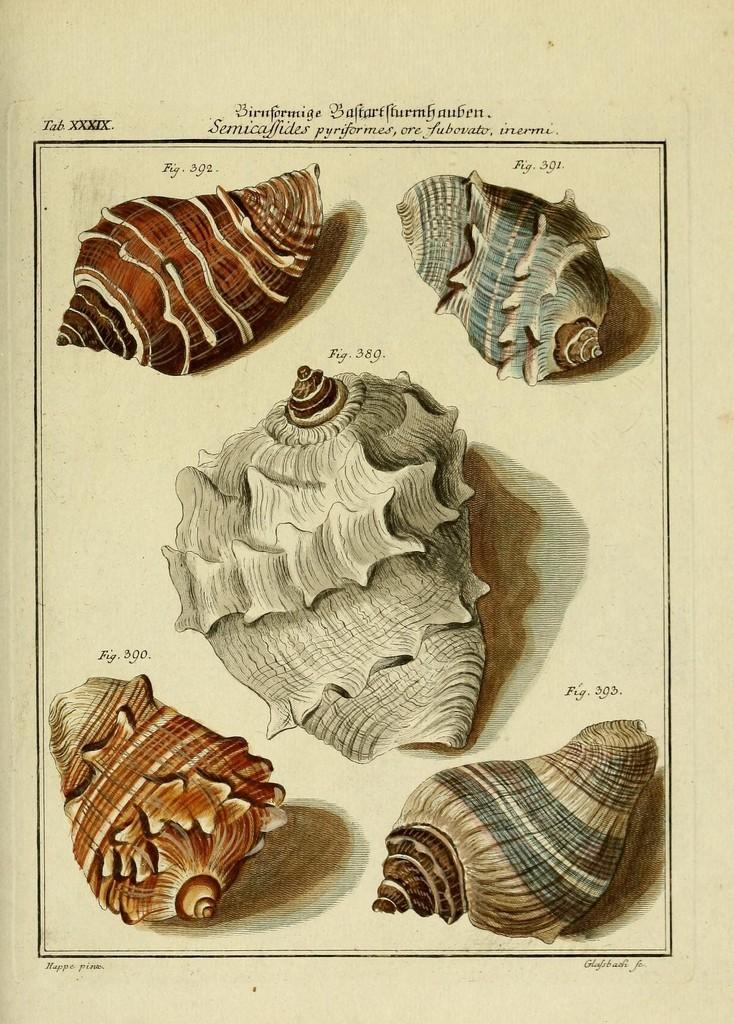What is depicted in the images in the picture? There are pictures of shells in the image. What is the medium on which the pictures are displayed? The pictures are on a paper. How many spades are used to dig the hole in the image? There are no spades or holes present in the image; it only features pictures of shells on a paper. 